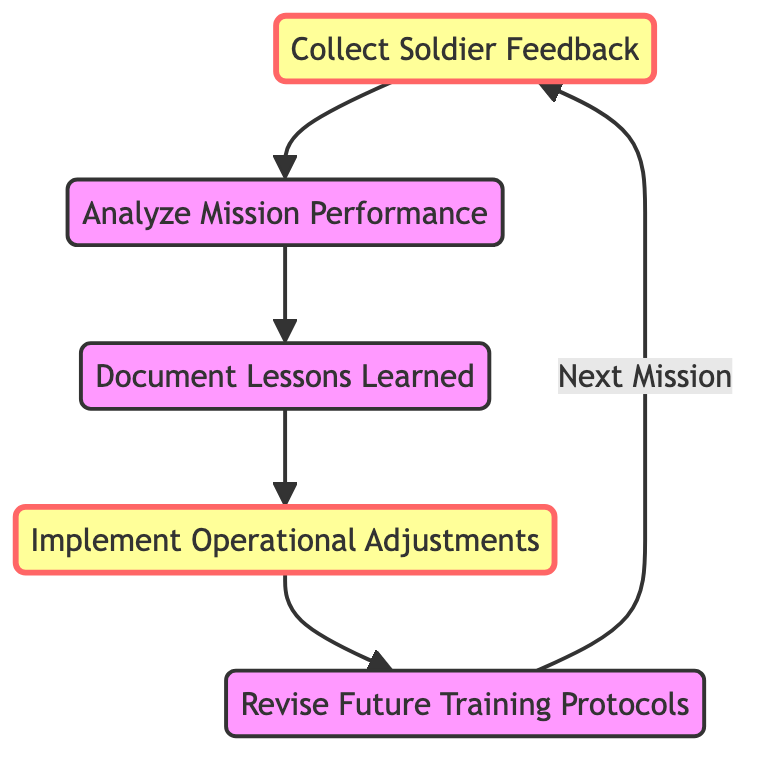What is the first node in the diagram? The first node represents the starting point of the after-action review loop, which is "Collect Soldier Feedback."
Answer: Collect Soldier Feedback How many nodes are in the directed graph? By counting each distinct element labeled in the diagram, there are five nodes in total: Collect Soldier Feedback, Analyze Mission Performance, Document Lessons Learned, Implement Operational Adjustments, and Revise Future Training Protocols.
Answer: 5 What is the last step in the process? The last step in the diagram loops back to the beginning step, which is "Collect Soldier Feedback," indicating that the cycle continues.
Answer: Collect Soldier Feedback Which node comes immediately after "Analyze Mission Performance"? The node that directly follows "Analyze Mission Performance" in the flow of the directed graph is "Document Lessons Learned."
Answer: Document Lessons Learned What nodes are classified as emphasis nodes? The emphasis nodes in the diagram are "Collect Soldier Feedback" and "Implement Operational Adjustments," which are visually distinct from the other nodes.
Answer: Collect Soldier Feedback, Implement Operational Adjustments What is the relationship between "Lessons Learned" and "Operational Adjustments"? The directed edge indicates a flow from "Lessons Learned" to "Operational Adjustments," meaning that lessons learned influence the adjustments made to operations.
Answer: Document Lessons Learned → Implement Operational Adjustments What is the total number of edges in the directed graph? By counting the lines connecting the nodes in the diagram, we find there are four edges connecting the nodes in the after-action review process.
Answer: 4 Which node is responsible for revising training protocols? The node indicating the responsibility for revising training protocols is "Revise Future Training Protocols," which follows the implementation of operational adjustments.
Answer: Revise Future Training Protocols What does the diagram suggest should happen after "Revise Future Training Protocols"? The diagram indicates that after "Revise Future Training Protocols," the process loops back to the starting point, which is "Collect Soldier Feedback."
Answer: Collect Soldier Feedback 